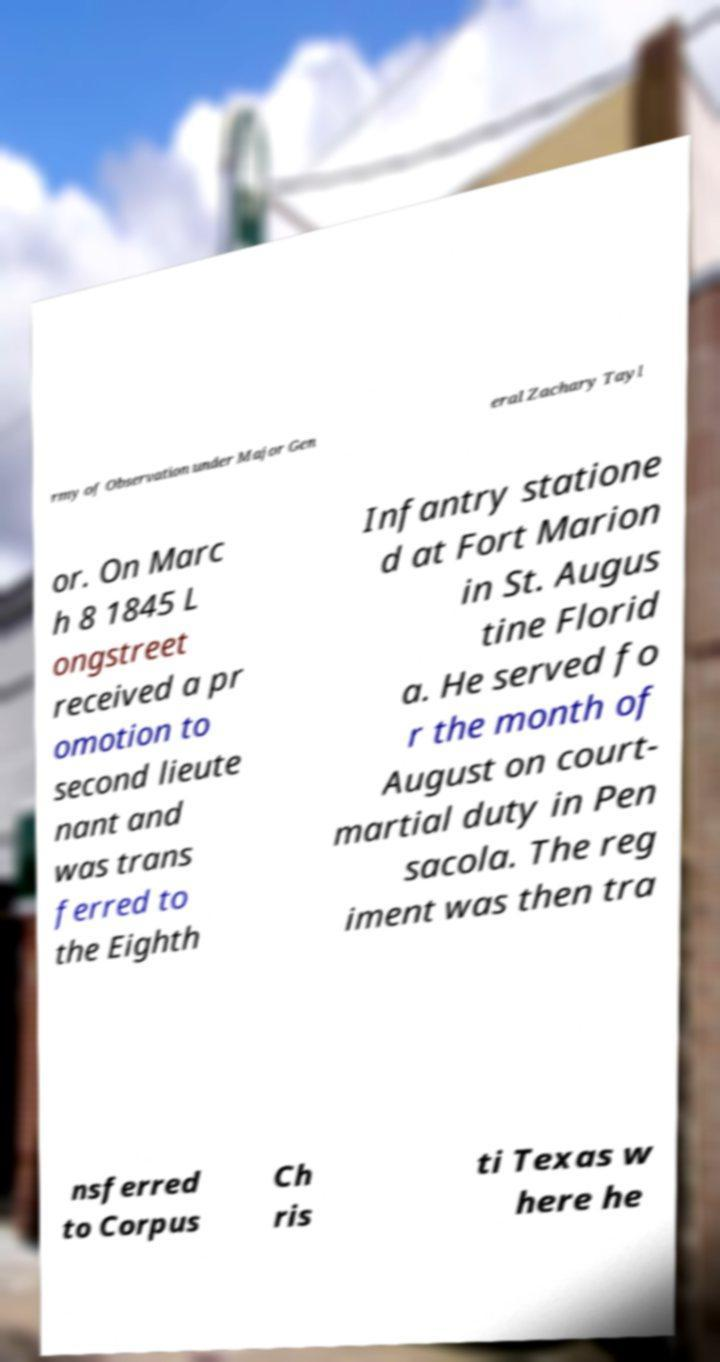There's text embedded in this image that I need extracted. Can you transcribe it verbatim? rmy of Observation under Major Gen eral Zachary Tayl or. On Marc h 8 1845 L ongstreet received a pr omotion to second lieute nant and was trans ferred to the Eighth Infantry statione d at Fort Marion in St. Augus tine Florid a. He served fo r the month of August on court- martial duty in Pen sacola. The reg iment was then tra nsferred to Corpus Ch ris ti Texas w here he 